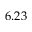Convert formula to latex. <formula><loc_0><loc_0><loc_500><loc_500>6 . 2 3</formula> 